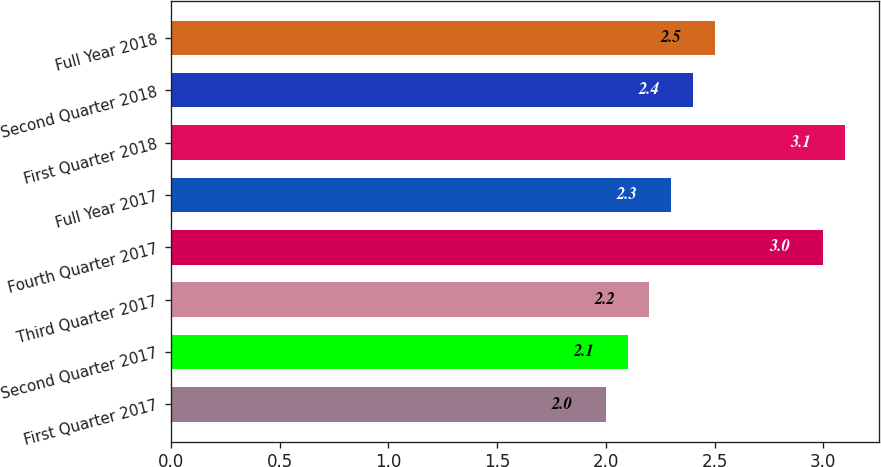Convert chart. <chart><loc_0><loc_0><loc_500><loc_500><bar_chart><fcel>First Quarter 2017<fcel>Second Quarter 2017<fcel>Third Quarter 2017<fcel>Fourth Quarter 2017<fcel>Full Year 2017<fcel>First Quarter 2018<fcel>Second Quarter 2018<fcel>Full Year 2018<nl><fcel>2<fcel>2.1<fcel>2.2<fcel>3<fcel>2.3<fcel>3.1<fcel>2.4<fcel>2.5<nl></chart> 